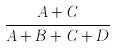Convert formula to latex. <formula><loc_0><loc_0><loc_500><loc_500>\frac { A + C } { A + B + C + D }</formula> 